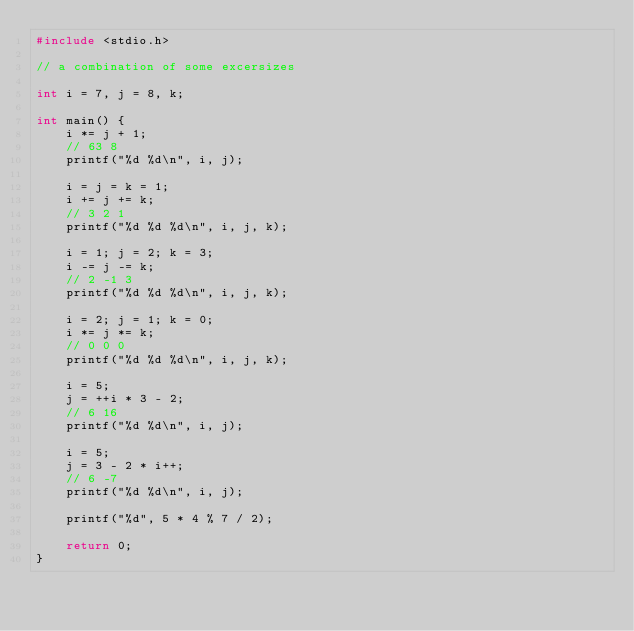<code> <loc_0><loc_0><loc_500><loc_500><_C_>#include <stdio.h>

// a combination of some excersizes

int i = 7, j = 8, k;

int main() {
    i *= j + 1;
    // 63 8
    printf("%d %d\n", i, j);

    i = j = k = 1;
    i += j += k;
    // 3 2 1
    printf("%d %d %d\n", i, j, k);

    i = 1; j = 2; k = 3;
    i -= j -= k;
    // 2 -1 3
    printf("%d %d %d\n", i, j, k);

    i = 2; j = 1; k = 0;
    i *= j *= k;
    // 0 0 0
    printf("%d %d %d\n", i, j, k);

    i = 5;
    j = ++i * 3 - 2;
    // 6 16
    printf("%d %d\n", i, j);

    i = 5;
    j = 3 - 2 * i++;
    // 6 -7
    printf("%d %d\n", i, j);

    printf("%d", 5 * 4 % 7 / 2);

    return 0;
}
</code> 